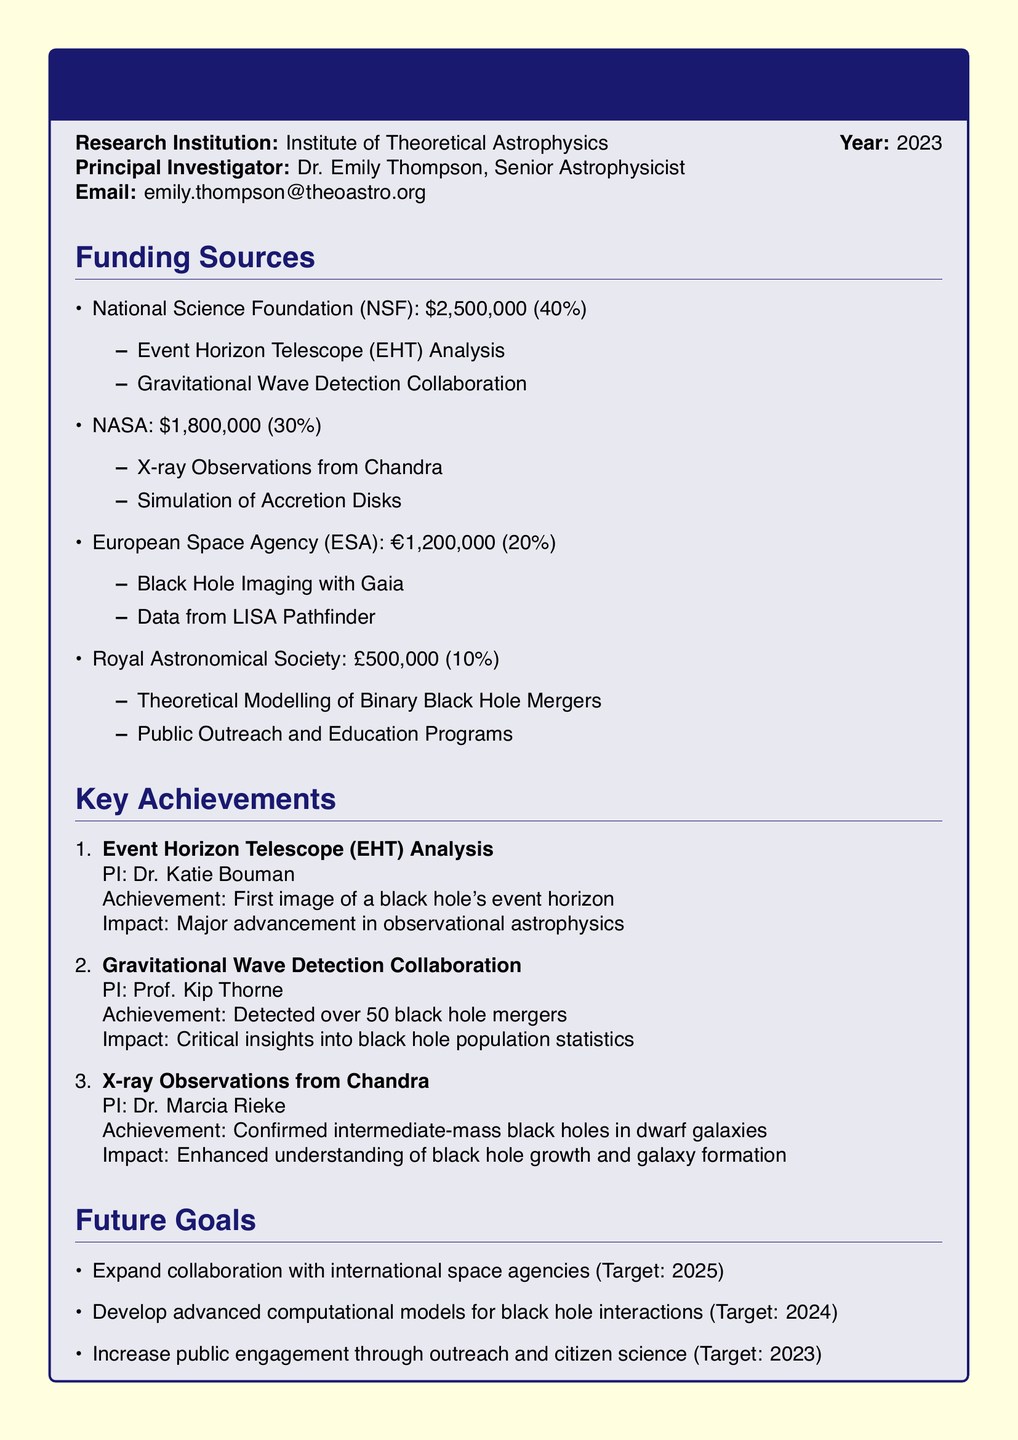What is the total funding from the National Science Foundation? The total funding from the NSF is specifically stated in the document, which is $2,500,000.
Answer: $2,500,000 Who is the Principal Investigator? The document mentions the Principal Investigator as Dr. Emily Thompson.
Answer: Dr. Emily Thompson What percentage of funding comes from NASA? NASA's funding percentage is explicitly listed in the document as 30%.
Answer: 30% What is one future goal mentioned in the document? The document lists multiple future goals, such as expanding collaboration with international space agencies.
Answer: Expand collaboration with international space agencies How many black hole mergers were detected in the Gravitational Wave Detection Collaboration? The document indicates that over 50 black hole mergers were detected in this project.
Answer: Over 50 What achievement is associated with the Event Horizon Telescope (EHT) Analysis? The document notes that the achievement of the EHT Analysis was the first image of a black hole's event horizon.
Answer: First image of a black hole's event horizon Which organization provided £500,000 in funding? The Royal Astronomical Society is the organization identified as providing £500,000 in funding.
Answer: Royal Astronomical Society What is the target year for developing advanced computational models? The document specifies that the target year for this goal is 2024.
Answer: 2024 